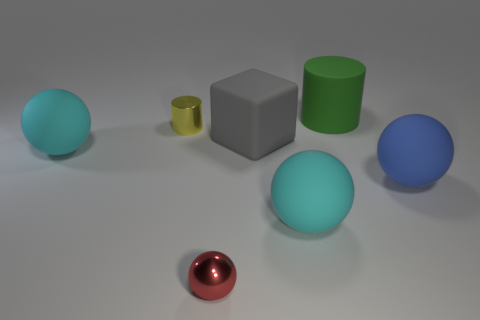Is there anything else of the same color as the tiny shiny sphere?
Offer a terse response. No. What shape is the object that is on the right side of the small yellow thing and to the left of the gray matte thing?
Ensure brevity in your answer.  Sphere. There is a rubber block left of the large blue rubber object; what size is it?
Give a very brief answer. Large. What number of large blue balls are on the left side of the big green cylinder that is behind the metal object that is in front of the small cylinder?
Your answer should be compact. 0. Are there any cylinders behind the big green cylinder?
Your answer should be very brief. No. How many other things are there of the same size as the red object?
Your answer should be very brief. 1. What is the big ball that is left of the big green matte cylinder and right of the tiny yellow shiny object made of?
Provide a short and direct response. Rubber. Do the large object that is to the left of the yellow cylinder and the large cyan object on the right side of the tiny yellow shiny cylinder have the same shape?
Ensure brevity in your answer.  Yes. Is there any other thing that is the same material as the green object?
Your answer should be very brief. Yes. There is a tiny thing that is behind the big cyan matte thing that is in front of the rubber ball that is on the right side of the large cylinder; what is its shape?
Offer a terse response. Cylinder. 